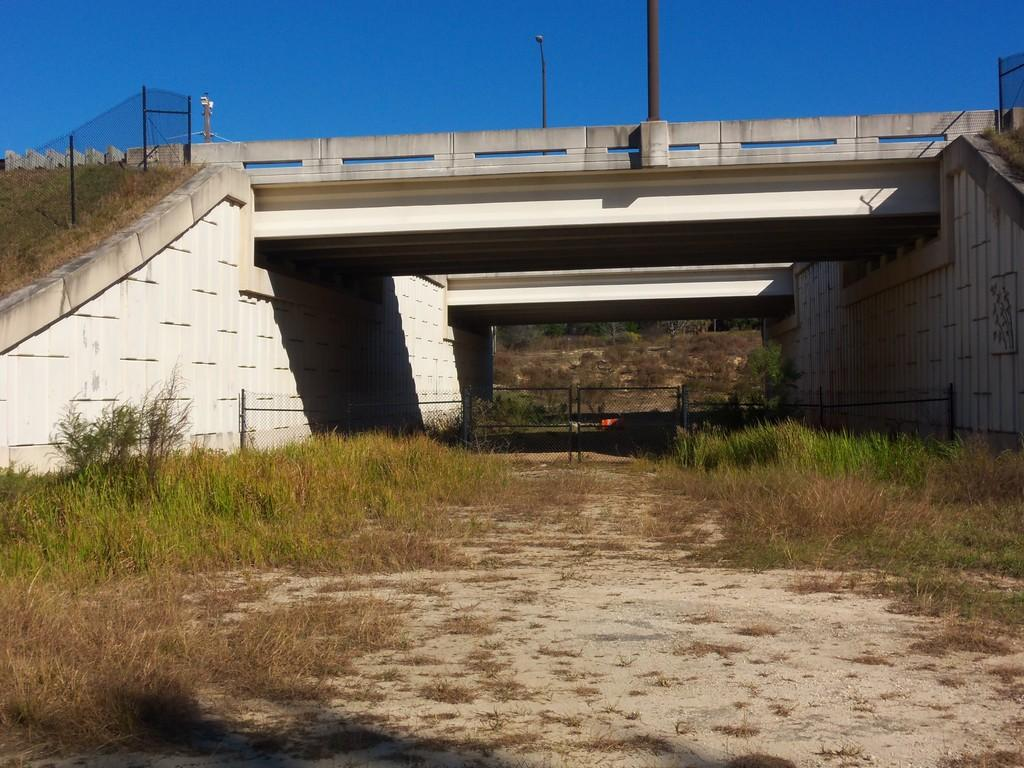What type of terrain is at the bottom of the image? There is grass at the bottom of the image. What structure is in the middle of the image? There is a bridge in the middle of the image. What can be seen on the bridge? There are poles on the bridge. What is visible behind the bridge? The sky is visible behind the bridge. Where are the beds located in the image? There are no beds present in the image. What type of drink is being served on the grass? There is no drink being served in the image; it only features grass, a bridge, poles, and the sky. 